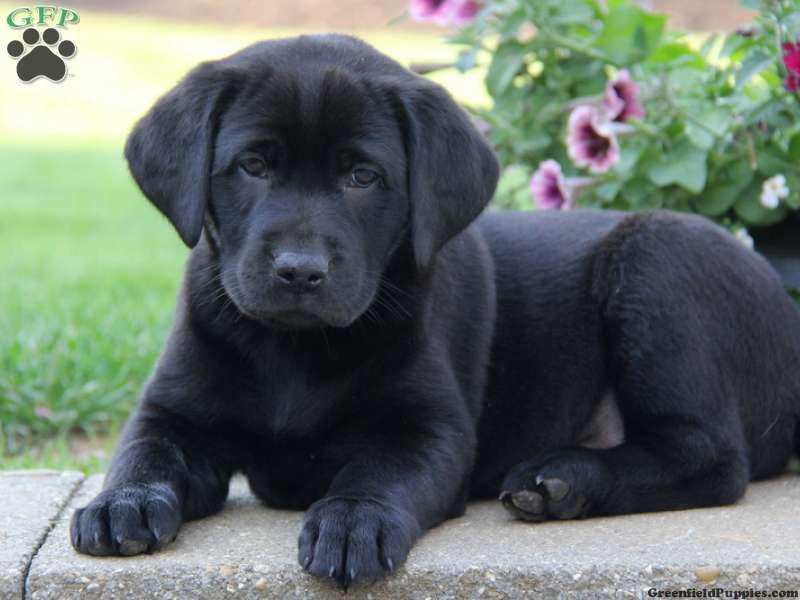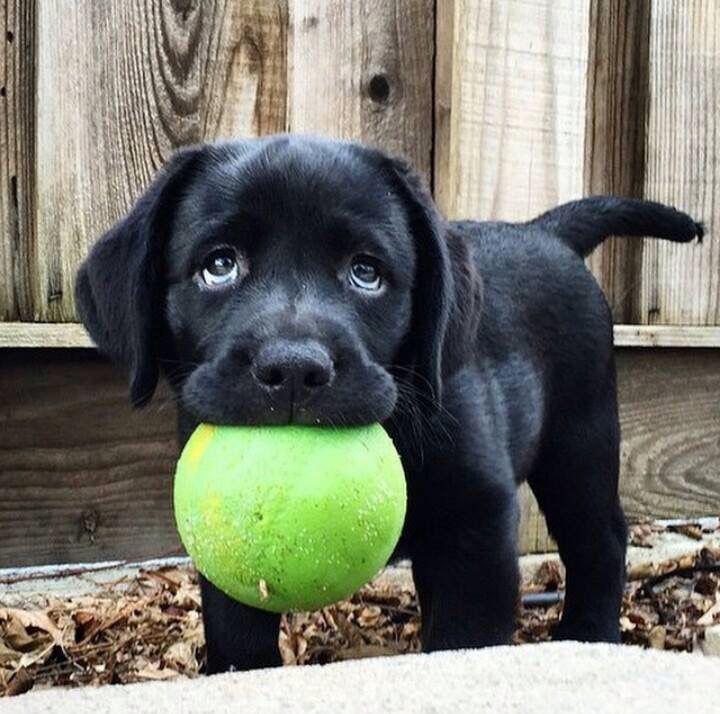The first image is the image on the left, the second image is the image on the right. Assess this claim about the two images: "One image contains at least two all-black lab puppies posed side-by-side outdoors.". Correct or not? Answer yes or no. No. The first image is the image on the left, the second image is the image on the right. Assess this claim about the two images: "The left image contains at least two black dogs.". Correct or not? Answer yes or no. No. 